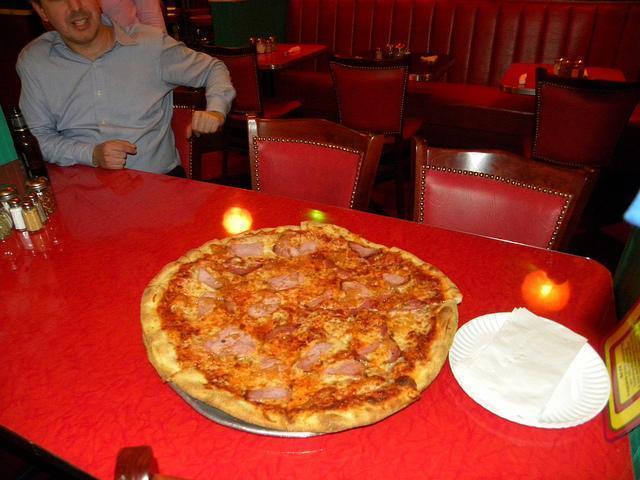How many candles on the table?
Give a very brief answer. 2. How many pizzas are there?
Give a very brief answer. 1. How many people can you see?
Give a very brief answer. 1. How many chairs are in the photo?
Give a very brief answer. 5. How many of the bears legs are bent?
Give a very brief answer. 0. 